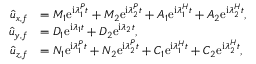<formula> <loc_0><loc_0><loc_500><loc_500>\begin{array} { r l } { \hat { u } _ { x , f } } & { = M _ { 1 } e ^ { i \lambda _ { 1 } ^ { P } t } + M _ { 2 } e ^ { i \lambda _ { 2 } ^ { P } t } + A _ { 1 } e ^ { i { \lambda } _ { 1 } ^ { H } t } + A _ { 2 } e ^ { i { \lambda } _ { 2 } ^ { H } t } , } \\ { \hat { u } _ { y , f } } & { = D _ { 1 } e ^ { i \lambda _ { 1 } t } + D _ { 2 } e ^ { i \lambda _ { 2 } t } , } \\ { \hat { u } _ { z , f } } & { = N _ { 1 } e ^ { i \lambda _ { 1 } ^ { P } t } + N _ { 2 } e ^ { i \lambda _ { 2 } ^ { P } t } + C _ { 1 } e ^ { i { \lambda } _ { 1 } ^ { H } t } + C _ { 2 } e ^ { i { \lambda } _ { 2 } ^ { H } t } , } \end{array}</formula> 